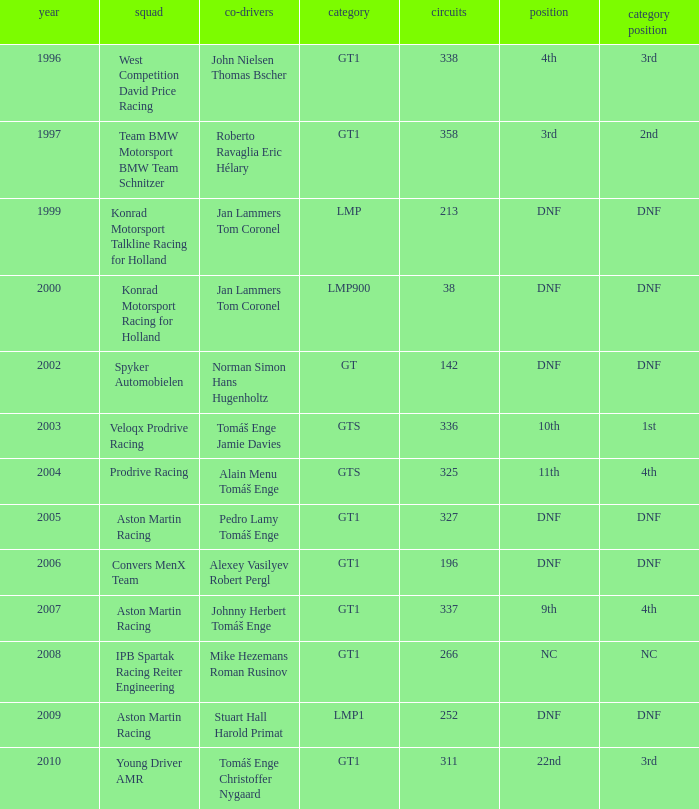Which position finished 3rd in class and completed less than 338 laps? 22nd. 